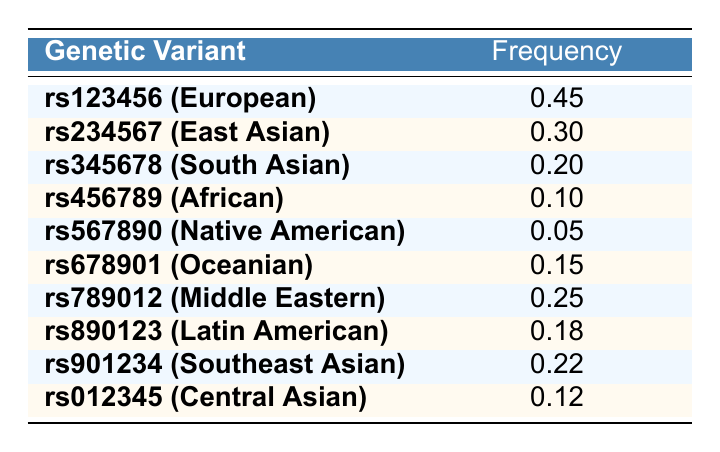What is the frequency of the rs123456 variant in Europeans? The table lists the frequency of the rs123456 variant specifically for the European population, which is directly stated as 0.45.
Answer: 0.45 Which population has the lowest genetic variant frequency? By reviewing the listed frequencies in the table, the Native American population has the lowest frequency at 0.05.
Answer: Native American What is the frequency of the rs789012 variant in the Middle Eastern population? Referring to the table, the frequency for the rs789012 variant is paired with the Middle Eastern population and is listed as 0.25.
Answer: 0.25 What is the average frequency of genetic variants across all populations listed? To find the average, sum all the frequencies: 0.45 + 0.30 + 0.20 + 0.10 + 0.05 + 0.15 + 0.25 + 0.18 + 0.22 + 0.12 = 1.92. There are 10 populations, so the average frequency is 1.92 / 10 = 0.192.
Answer: 0.192 Is the frequency of the rs678901 variant greater than the frequency of the rs567890 variant? The frequency for rs678901 (Oceanian) is 0.15, while rs567890 (Native American) has a frequency of 0.05. Since 0.15 is greater than 0.05, the statement is true.
Answer: Yes If we consider only the Asian populations, which one has the highest frequency and what is its value? Referring to the table, the relevant Asian populations are East Asian (0.30), South Asian (0.20), and Southeast Asian (0.22). The highest frequency among these is the East Asian population with a frequency of 0.30.
Answer: East Asian, 0.30 What is the difference in frequency between the European and African populations? The frequency for Europeans (rs123456) is 0.45 and for Africans (rs456789) is 0.10. The difference is calculated as 0.45 - 0.10 = 0.35.
Answer: 0.35 How many populations have a frequency greater than 0.20? The populations with frequencies greater than 0.20 are: European (0.45), East Asian (0.30), and Middle Eastern (0.25). There are 3 populations with a frequency above 0.20.
Answer: 3 What is the frequency of the rs901234 variant in the Southeast Asian population? The frequency of the rs901234 variant when paired with the Southeast Asian population is listed as 0.22 in the table.
Answer: 0.22 Is it true that the combined frequency of the African and Native American populations exceeds 0.15? The frequency for the African population is 0.10 and for the Native American population is 0.05. Combined, their frequency totals 0.10 + 0.05 = 0.15, which does not exceed 0.15. Therefore, it is false.
Answer: No 